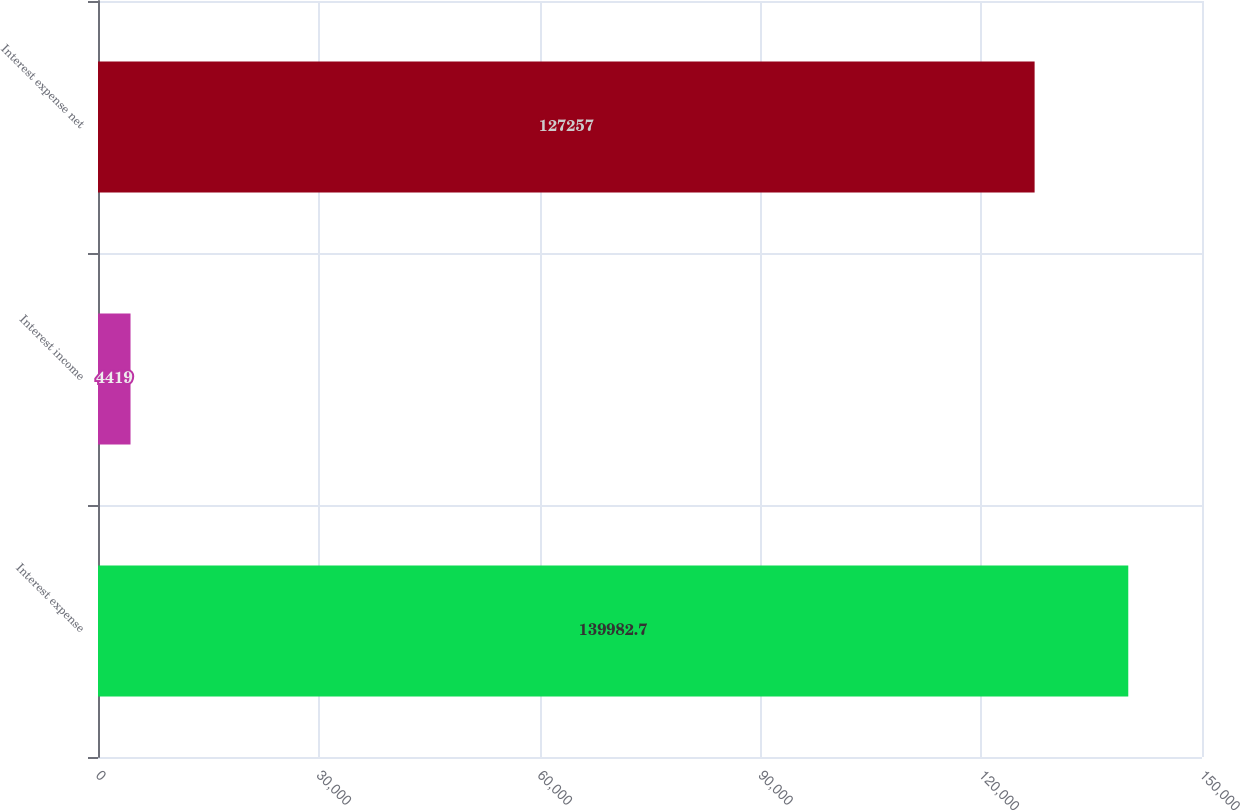Convert chart to OTSL. <chart><loc_0><loc_0><loc_500><loc_500><bar_chart><fcel>Interest expense<fcel>Interest income<fcel>Interest expense net<nl><fcel>139983<fcel>4419<fcel>127257<nl></chart> 